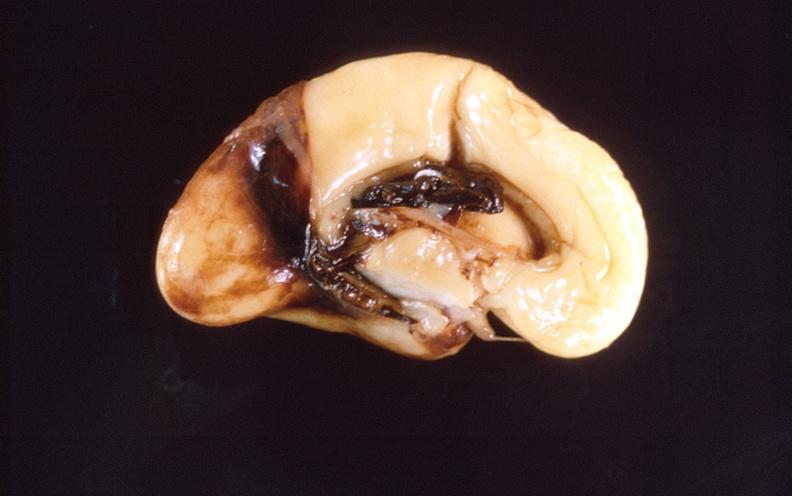s nervous present?
Answer the question using a single word or phrase. Yes 